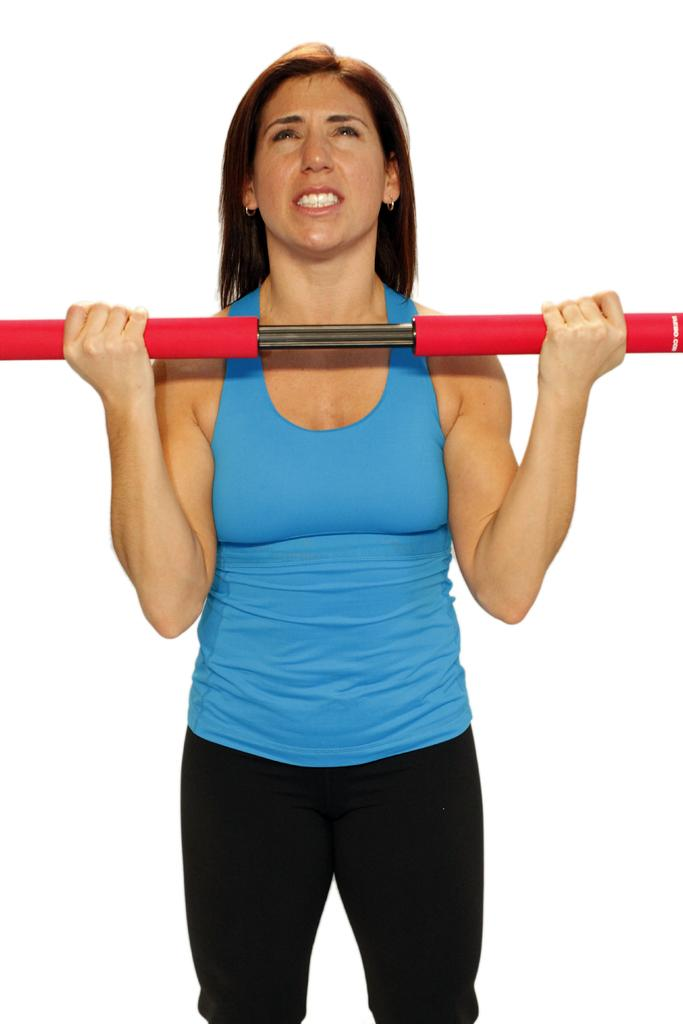Who is the main subject in the image? There is a woman in the image. What is the woman doing in the image? The woman is standing in the image. What object is the woman holding in her hand? The woman is holding an iron rod in her hand. What type of camera is the woman using to capture the fight in the image? There is no camera or fight present in the image; it only features a woman holding an iron rod. 